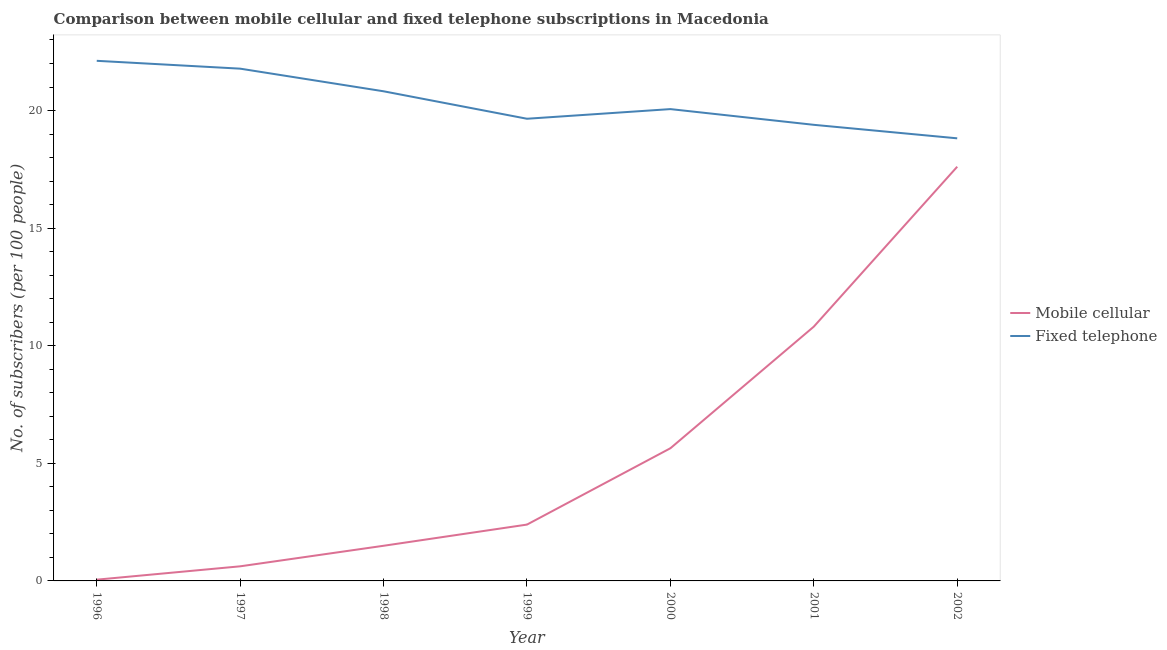How many different coloured lines are there?
Make the answer very short. 2. Does the line corresponding to number of fixed telephone subscribers intersect with the line corresponding to number of mobile cellular subscribers?
Your response must be concise. No. Is the number of lines equal to the number of legend labels?
Your answer should be very brief. Yes. What is the number of fixed telephone subscribers in 2002?
Give a very brief answer. 18.82. Across all years, what is the maximum number of fixed telephone subscribers?
Provide a short and direct response. 22.11. Across all years, what is the minimum number of mobile cellular subscribers?
Make the answer very short. 0.05. What is the total number of fixed telephone subscribers in the graph?
Your answer should be very brief. 142.63. What is the difference between the number of mobile cellular subscribers in 1997 and that in 2001?
Provide a short and direct response. -10.19. What is the difference between the number of mobile cellular subscribers in 2002 and the number of fixed telephone subscribers in 2001?
Your answer should be very brief. -1.78. What is the average number of fixed telephone subscribers per year?
Your response must be concise. 20.38. In the year 2002, what is the difference between the number of fixed telephone subscribers and number of mobile cellular subscribers?
Offer a very short reply. 1.21. What is the ratio of the number of mobile cellular subscribers in 1998 to that in 2000?
Provide a succinct answer. 0.26. Is the number of mobile cellular subscribers in 1997 less than that in 2000?
Ensure brevity in your answer.  Yes. What is the difference between the highest and the second highest number of mobile cellular subscribers?
Provide a succinct answer. 6.8. What is the difference between the highest and the lowest number of mobile cellular subscribers?
Your response must be concise. 17.56. In how many years, is the number of mobile cellular subscribers greater than the average number of mobile cellular subscribers taken over all years?
Give a very brief answer. 3. Is the sum of the number of mobile cellular subscribers in 1997 and 2001 greater than the maximum number of fixed telephone subscribers across all years?
Give a very brief answer. No. Is the number of fixed telephone subscribers strictly greater than the number of mobile cellular subscribers over the years?
Provide a short and direct response. Yes. How many lines are there?
Offer a terse response. 2. What is the difference between two consecutive major ticks on the Y-axis?
Your answer should be compact. 5. Are the values on the major ticks of Y-axis written in scientific E-notation?
Provide a succinct answer. No. Does the graph contain any zero values?
Ensure brevity in your answer.  No. Where does the legend appear in the graph?
Your answer should be very brief. Center right. How are the legend labels stacked?
Make the answer very short. Vertical. What is the title of the graph?
Give a very brief answer. Comparison between mobile cellular and fixed telephone subscriptions in Macedonia. Does "Pregnant women" appear as one of the legend labels in the graph?
Provide a succinct answer. No. What is the label or title of the X-axis?
Make the answer very short. Year. What is the label or title of the Y-axis?
Your answer should be very brief. No. of subscribers (per 100 people). What is the No. of subscribers (per 100 people) of Mobile cellular in 1996?
Keep it short and to the point. 0.05. What is the No. of subscribers (per 100 people) in Fixed telephone in 1996?
Your answer should be compact. 22.11. What is the No. of subscribers (per 100 people) of Mobile cellular in 1997?
Ensure brevity in your answer.  0.62. What is the No. of subscribers (per 100 people) of Fixed telephone in 1997?
Provide a short and direct response. 21.78. What is the No. of subscribers (per 100 people) in Mobile cellular in 1998?
Offer a terse response. 1.49. What is the No. of subscribers (per 100 people) in Fixed telephone in 1998?
Make the answer very short. 20.82. What is the No. of subscribers (per 100 people) of Mobile cellular in 1999?
Your answer should be compact. 2.4. What is the No. of subscribers (per 100 people) in Fixed telephone in 1999?
Make the answer very short. 19.65. What is the No. of subscribers (per 100 people) in Mobile cellular in 2000?
Provide a succinct answer. 5.64. What is the No. of subscribers (per 100 people) in Fixed telephone in 2000?
Provide a short and direct response. 20.06. What is the No. of subscribers (per 100 people) of Mobile cellular in 2001?
Make the answer very short. 10.81. What is the No. of subscribers (per 100 people) in Fixed telephone in 2001?
Ensure brevity in your answer.  19.39. What is the No. of subscribers (per 100 people) of Mobile cellular in 2002?
Give a very brief answer. 17.61. What is the No. of subscribers (per 100 people) in Fixed telephone in 2002?
Keep it short and to the point. 18.82. Across all years, what is the maximum No. of subscribers (per 100 people) in Mobile cellular?
Provide a succinct answer. 17.61. Across all years, what is the maximum No. of subscribers (per 100 people) of Fixed telephone?
Make the answer very short. 22.11. Across all years, what is the minimum No. of subscribers (per 100 people) of Mobile cellular?
Provide a short and direct response. 0.05. Across all years, what is the minimum No. of subscribers (per 100 people) of Fixed telephone?
Offer a terse response. 18.82. What is the total No. of subscribers (per 100 people) of Mobile cellular in the graph?
Make the answer very short. 38.63. What is the total No. of subscribers (per 100 people) of Fixed telephone in the graph?
Your answer should be very brief. 142.63. What is the difference between the No. of subscribers (per 100 people) of Mobile cellular in 1996 and that in 1997?
Ensure brevity in your answer.  -0.57. What is the difference between the No. of subscribers (per 100 people) of Fixed telephone in 1996 and that in 1997?
Your answer should be very brief. 0.33. What is the difference between the No. of subscribers (per 100 people) in Mobile cellular in 1996 and that in 1998?
Ensure brevity in your answer.  -1.44. What is the difference between the No. of subscribers (per 100 people) in Fixed telephone in 1996 and that in 1998?
Your answer should be compact. 1.3. What is the difference between the No. of subscribers (per 100 people) of Mobile cellular in 1996 and that in 1999?
Your answer should be compact. -2.34. What is the difference between the No. of subscribers (per 100 people) of Fixed telephone in 1996 and that in 1999?
Make the answer very short. 2.46. What is the difference between the No. of subscribers (per 100 people) in Mobile cellular in 1996 and that in 2000?
Make the answer very short. -5.59. What is the difference between the No. of subscribers (per 100 people) of Fixed telephone in 1996 and that in 2000?
Your response must be concise. 2.05. What is the difference between the No. of subscribers (per 100 people) in Mobile cellular in 1996 and that in 2001?
Provide a short and direct response. -10.76. What is the difference between the No. of subscribers (per 100 people) in Fixed telephone in 1996 and that in 2001?
Ensure brevity in your answer.  2.72. What is the difference between the No. of subscribers (per 100 people) of Mobile cellular in 1996 and that in 2002?
Make the answer very short. -17.56. What is the difference between the No. of subscribers (per 100 people) of Fixed telephone in 1996 and that in 2002?
Offer a terse response. 3.3. What is the difference between the No. of subscribers (per 100 people) of Mobile cellular in 1997 and that in 1998?
Your answer should be very brief. -0.87. What is the difference between the No. of subscribers (per 100 people) of Fixed telephone in 1997 and that in 1998?
Offer a terse response. 0.96. What is the difference between the No. of subscribers (per 100 people) in Mobile cellular in 1997 and that in 1999?
Keep it short and to the point. -1.77. What is the difference between the No. of subscribers (per 100 people) in Fixed telephone in 1997 and that in 1999?
Provide a short and direct response. 2.13. What is the difference between the No. of subscribers (per 100 people) in Mobile cellular in 1997 and that in 2000?
Your answer should be very brief. -5.02. What is the difference between the No. of subscribers (per 100 people) in Fixed telephone in 1997 and that in 2000?
Ensure brevity in your answer.  1.72. What is the difference between the No. of subscribers (per 100 people) of Mobile cellular in 1997 and that in 2001?
Your answer should be compact. -10.19. What is the difference between the No. of subscribers (per 100 people) of Fixed telephone in 1997 and that in 2001?
Provide a succinct answer. 2.39. What is the difference between the No. of subscribers (per 100 people) of Mobile cellular in 1997 and that in 2002?
Your answer should be compact. -16.99. What is the difference between the No. of subscribers (per 100 people) of Fixed telephone in 1997 and that in 2002?
Your answer should be compact. 2.96. What is the difference between the No. of subscribers (per 100 people) in Mobile cellular in 1998 and that in 1999?
Your response must be concise. -0.9. What is the difference between the No. of subscribers (per 100 people) of Fixed telephone in 1998 and that in 1999?
Keep it short and to the point. 1.17. What is the difference between the No. of subscribers (per 100 people) of Mobile cellular in 1998 and that in 2000?
Make the answer very short. -4.15. What is the difference between the No. of subscribers (per 100 people) in Fixed telephone in 1998 and that in 2000?
Your answer should be very brief. 0.76. What is the difference between the No. of subscribers (per 100 people) in Mobile cellular in 1998 and that in 2001?
Ensure brevity in your answer.  -9.32. What is the difference between the No. of subscribers (per 100 people) of Fixed telephone in 1998 and that in 2001?
Ensure brevity in your answer.  1.43. What is the difference between the No. of subscribers (per 100 people) of Mobile cellular in 1998 and that in 2002?
Provide a succinct answer. -16.12. What is the difference between the No. of subscribers (per 100 people) in Fixed telephone in 1998 and that in 2002?
Your response must be concise. 2. What is the difference between the No. of subscribers (per 100 people) of Mobile cellular in 1999 and that in 2000?
Your response must be concise. -3.25. What is the difference between the No. of subscribers (per 100 people) in Fixed telephone in 1999 and that in 2000?
Offer a terse response. -0.41. What is the difference between the No. of subscribers (per 100 people) in Mobile cellular in 1999 and that in 2001?
Keep it short and to the point. -8.42. What is the difference between the No. of subscribers (per 100 people) of Fixed telephone in 1999 and that in 2001?
Keep it short and to the point. 0.26. What is the difference between the No. of subscribers (per 100 people) of Mobile cellular in 1999 and that in 2002?
Your response must be concise. -15.22. What is the difference between the No. of subscribers (per 100 people) of Fixed telephone in 1999 and that in 2002?
Offer a terse response. 0.83. What is the difference between the No. of subscribers (per 100 people) in Mobile cellular in 2000 and that in 2001?
Provide a short and direct response. -5.17. What is the difference between the No. of subscribers (per 100 people) in Fixed telephone in 2000 and that in 2001?
Give a very brief answer. 0.67. What is the difference between the No. of subscribers (per 100 people) of Mobile cellular in 2000 and that in 2002?
Make the answer very short. -11.97. What is the difference between the No. of subscribers (per 100 people) in Fixed telephone in 2000 and that in 2002?
Your answer should be compact. 1.24. What is the difference between the No. of subscribers (per 100 people) of Mobile cellular in 2001 and that in 2002?
Keep it short and to the point. -6.8. What is the difference between the No. of subscribers (per 100 people) of Fixed telephone in 2001 and that in 2002?
Offer a very short reply. 0.57. What is the difference between the No. of subscribers (per 100 people) in Mobile cellular in 1996 and the No. of subscribers (per 100 people) in Fixed telephone in 1997?
Offer a very short reply. -21.73. What is the difference between the No. of subscribers (per 100 people) of Mobile cellular in 1996 and the No. of subscribers (per 100 people) of Fixed telephone in 1998?
Offer a very short reply. -20.76. What is the difference between the No. of subscribers (per 100 people) in Mobile cellular in 1996 and the No. of subscribers (per 100 people) in Fixed telephone in 1999?
Offer a very short reply. -19.6. What is the difference between the No. of subscribers (per 100 people) of Mobile cellular in 1996 and the No. of subscribers (per 100 people) of Fixed telephone in 2000?
Give a very brief answer. -20.01. What is the difference between the No. of subscribers (per 100 people) in Mobile cellular in 1996 and the No. of subscribers (per 100 people) in Fixed telephone in 2001?
Provide a short and direct response. -19.34. What is the difference between the No. of subscribers (per 100 people) in Mobile cellular in 1996 and the No. of subscribers (per 100 people) in Fixed telephone in 2002?
Make the answer very short. -18.76. What is the difference between the No. of subscribers (per 100 people) in Mobile cellular in 1997 and the No. of subscribers (per 100 people) in Fixed telephone in 1998?
Offer a very short reply. -20.2. What is the difference between the No. of subscribers (per 100 people) of Mobile cellular in 1997 and the No. of subscribers (per 100 people) of Fixed telephone in 1999?
Provide a succinct answer. -19.03. What is the difference between the No. of subscribers (per 100 people) in Mobile cellular in 1997 and the No. of subscribers (per 100 people) in Fixed telephone in 2000?
Offer a terse response. -19.44. What is the difference between the No. of subscribers (per 100 people) in Mobile cellular in 1997 and the No. of subscribers (per 100 people) in Fixed telephone in 2001?
Make the answer very short. -18.77. What is the difference between the No. of subscribers (per 100 people) of Mobile cellular in 1997 and the No. of subscribers (per 100 people) of Fixed telephone in 2002?
Make the answer very short. -18.2. What is the difference between the No. of subscribers (per 100 people) of Mobile cellular in 1998 and the No. of subscribers (per 100 people) of Fixed telephone in 1999?
Ensure brevity in your answer.  -18.16. What is the difference between the No. of subscribers (per 100 people) of Mobile cellular in 1998 and the No. of subscribers (per 100 people) of Fixed telephone in 2000?
Keep it short and to the point. -18.57. What is the difference between the No. of subscribers (per 100 people) in Mobile cellular in 1998 and the No. of subscribers (per 100 people) in Fixed telephone in 2001?
Offer a very short reply. -17.9. What is the difference between the No. of subscribers (per 100 people) of Mobile cellular in 1998 and the No. of subscribers (per 100 people) of Fixed telephone in 2002?
Your answer should be very brief. -17.32. What is the difference between the No. of subscribers (per 100 people) in Mobile cellular in 1999 and the No. of subscribers (per 100 people) in Fixed telephone in 2000?
Provide a short and direct response. -17.67. What is the difference between the No. of subscribers (per 100 people) of Mobile cellular in 1999 and the No. of subscribers (per 100 people) of Fixed telephone in 2001?
Provide a short and direct response. -17. What is the difference between the No. of subscribers (per 100 people) of Mobile cellular in 1999 and the No. of subscribers (per 100 people) of Fixed telephone in 2002?
Your answer should be very brief. -16.42. What is the difference between the No. of subscribers (per 100 people) of Mobile cellular in 2000 and the No. of subscribers (per 100 people) of Fixed telephone in 2001?
Your answer should be very brief. -13.75. What is the difference between the No. of subscribers (per 100 people) of Mobile cellular in 2000 and the No. of subscribers (per 100 people) of Fixed telephone in 2002?
Give a very brief answer. -13.18. What is the difference between the No. of subscribers (per 100 people) of Mobile cellular in 2001 and the No. of subscribers (per 100 people) of Fixed telephone in 2002?
Give a very brief answer. -8.01. What is the average No. of subscribers (per 100 people) in Mobile cellular per year?
Offer a very short reply. 5.52. What is the average No. of subscribers (per 100 people) in Fixed telephone per year?
Offer a terse response. 20.38. In the year 1996, what is the difference between the No. of subscribers (per 100 people) of Mobile cellular and No. of subscribers (per 100 people) of Fixed telephone?
Provide a short and direct response. -22.06. In the year 1997, what is the difference between the No. of subscribers (per 100 people) of Mobile cellular and No. of subscribers (per 100 people) of Fixed telephone?
Make the answer very short. -21.16. In the year 1998, what is the difference between the No. of subscribers (per 100 people) of Mobile cellular and No. of subscribers (per 100 people) of Fixed telephone?
Your response must be concise. -19.32. In the year 1999, what is the difference between the No. of subscribers (per 100 people) in Mobile cellular and No. of subscribers (per 100 people) in Fixed telephone?
Ensure brevity in your answer.  -17.25. In the year 2000, what is the difference between the No. of subscribers (per 100 people) of Mobile cellular and No. of subscribers (per 100 people) of Fixed telephone?
Give a very brief answer. -14.42. In the year 2001, what is the difference between the No. of subscribers (per 100 people) of Mobile cellular and No. of subscribers (per 100 people) of Fixed telephone?
Provide a short and direct response. -8.58. In the year 2002, what is the difference between the No. of subscribers (per 100 people) of Mobile cellular and No. of subscribers (per 100 people) of Fixed telephone?
Offer a terse response. -1.21. What is the ratio of the No. of subscribers (per 100 people) of Mobile cellular in 1996 to that in 1997?
Make the answer very short. 0.09. What is the ratio of the No. of subscribers (per 100 people) of Fixed telephone in 1996 to that in 1997?
Provide a succinct answer. 1.02. What is the ratio of the No. of subscribers (per 100 people) in Mobile cellular in 1996 to that in 1998?
Keep it short and to the point. 0.04. What is the ratio of the No. of subscribers (per 100 people) in Fixed telephone in 1996 to that in 1998?
Give a very brief answer. 1.06. What is the ratio of the No. of subscribers (per 100 people) in Mobile cellular in 1996 to that in 1999?
Make the answer very short. 0.02. What is the ratio of the No. of subscribers (per 100 people) of Fixed telephone in 1996 to that in 1999?
Keep it short and to the point. 1.13. What is the ratio of the No. of subscribers (per 100 people) of Mobile cellular in 1996 to that in 2000?
Make the answer very short. 0.01. What is the ratio of the No. of subscribers (per 100 people) of Fixed telephone in 1996 to that in 2000?
Give a very brief answer. 1.1. What is the ratio of the No. of subscribers (per 100 people) in Mobile cellular in 1996 to that in 2001?
Offer a terse response. 0.01. What is the ratio of the No. of subscribers (per 100 people) of Fixed telephone in 1996 to that in 2001?
Keep it short and to the point. 1.14. What is the ratio of the No. of subscribers (per 100 people) in Mobile cellular in 1996 to that in 2002?
Provide a succinct answer. 0. What is the ratio of the No. of subscribers (per 100 people) of Fixed telephone in 1996 to that in 2002?
Ensure brevity in your answer.  1.18. What is the ratio of the No. of subscribers (per 100 people) of Mobile cellular in 1997 to that in 1998?
Offer a very short reply. 0.42. What is the ratio of the No. of subscribers (per 100 people) of Fixed telephone in 1997 to that in 1998?
Keep it short and to the point. 1.05. What is the ratio of the No. of subscribers (per 100 people) of Mobile cellular in 1997 to that in 1999?
Give a very brief answer. 0.26. What is the ratio of the No. of subscribers (per 100 people) in Fixed telephone in 1997 to that in 1999?
Give a very brief answer. 1.11. What is the ratio of the No. of subscribers (per 100 people) of Mobile cellular in 1997 to that in 2000?
Keep it short and to the point. 0.11. What is the ratio of the No. of subscribers (per 100 people) of Fixed telephone in 1997 to that in 2000?
Keep it short and to the point. 1.09. What is the ratio of the No. of subscribers (per 100 people) in Mobile cellular in 1997 to that in 2001?
Your answer should be very brief. 0.06. What is the ratio of the No. of subscribers (per 100 people) in Fixed telephone in 1997 to that in 2001?
Provide a succinct answer. 1.12. What is the ratio of the No. of subscribers (per 100 people) of Mobile cellular in 1997 to that in 2002?
Offer a very short reply. 0.04. What is the ratio of the No. of subscribers (per 100 people) of Fixed telephone in 1997 to that in 2002?
Make the answer very short. 1.16. What is the ratio of the No. of subscribers (per 100 people) of Mobile cellular in 1998 to that in 1999?
Make the answer very short. 0.62. What is the ratio of the No. of subscribers (per 100 people) of Fixed telephone in 1998 to that in 1999?
Your answer should be very brief. 1.06. What is the ratio of the No. of subscribers (per 100 people) in Mobile cellular in 1998 to that in 2000?
Offer a terse response. 0.27. What is the ratio of the No. of subscribers (per 100 people) in Fixed telephone in 1998 to that in 2000?
Your answer should be compact. 1.04. What is the ratio of the No. of subscribers (per 100 people) of Mobile cellular in 1998 to that in 2001?
Offer a very short reply. 0.14. What is the ratio of the No. of subscribers (per 100 people) in Fixed telephone in 1998 to that in 2001?
Your answer should be very brief. 1.07. What is the ratio of the No. of subscribers (per 100 people) in Mobile cellular in 1998 to that in 2002?
Provide a succinct answer. 0.08. What is the ratio of the No. of subscribers (per 100 people) in Fixed telephone in 1998 to that in 2002?
Make the answer very short. 1.11. What is the ratio of the No. of subscribers (per 100 people) of Mobile cellular in 1999 to that in 2000?
Give a very brief answer. 0.42. What is the ratio of the No. of subscribers (per 100 people) of Fixed telephone in 1999 to that in 2000?
Offer a terse response. 0.98. What is the ratio of the No. of subscribers (per 100 people) in Mobile cellular in 1999 to that in 2001?
Your answer should be compact. 0.22. What is the ratio of the No. of subscribers (per 100 people) of Fixed telephone in 1999 to that in 2001?
Offer a terse response. 1.01. What is the ratio of the No. of subscribers (per 100 people) of Mobile cellular in 1999 to that in 2002?
Keep it short and to the point. 0.14. What is the ratio of the No. of subscribers (per 100 people) in Fixed telephone in 1999 to that in 2002?
Your answer should be very brief. 1.04. What is the ratio of the No. of subscribers (per 100 people) in Mobile cellular in 2000 to that in 2001?
Provide a short and direct response. 0.52. What is the ratio of the No. of subscribers (per 100 people) in Fixed telephone in 2000 to that in 2001?
Your answer should be very brief. 1.03. What is the ratio of the No. of subscribers (per 100 people) of Mobile cellular in 2000 to that in 2002?
Your response must be concise. 0.32. What is the ratio of the No. of subscribers (per 100 people) in Fixed telephone in 2000 to that in 2002?
Provide a succinct answer. 1.07. What is the ratio of the No. of subscribers (per 100 people) in Mobile cellular in 2001 to that in 2002?
Your answer should be compact. 0.61. What is the ratio of the No. of subscribers (per 100 people) of Fixed telephone in 2001 to that in 2002?
Keep it short and to the point. 1.03. What is the difference between the highest and the second highest No. of subscribers (per 100 people) in Mobile cellular?
Offer a very short reply. 6.8. What is the difference between the highest and the second highest No. of subscribers (per 100 people) in Fixed telephone?
Provide a succinct answer. 0.33. What is the difference between the highest and the lowest No. of subscribers (per 100 people) in Mobile cellular?
Offer a terse response. 17.56. What is the difference between the highest and the lowest No. of subscribers (per 100 people) of Fixed telephone?
Your answer should be very brief. 3.3. 